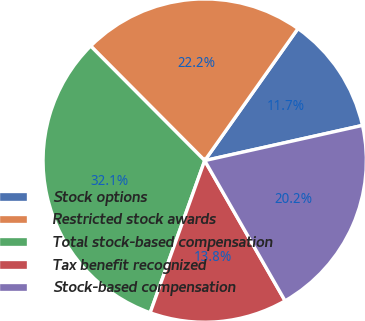Convert chart to OTSL. <chart><loc_0><loc_0><loc_500><loc_500><pie_chart><fcel>Stock options<fcel>Restricted stock awards<fcel>Total stock-based compensation<fcel>Tax benefit recognized<fcel>Stock-based compensation<nl><fcel>11.72%<fcel>22.25%<fcel>32.06%<fcel>13.76%<fcel>20.21%<nl></chart> 